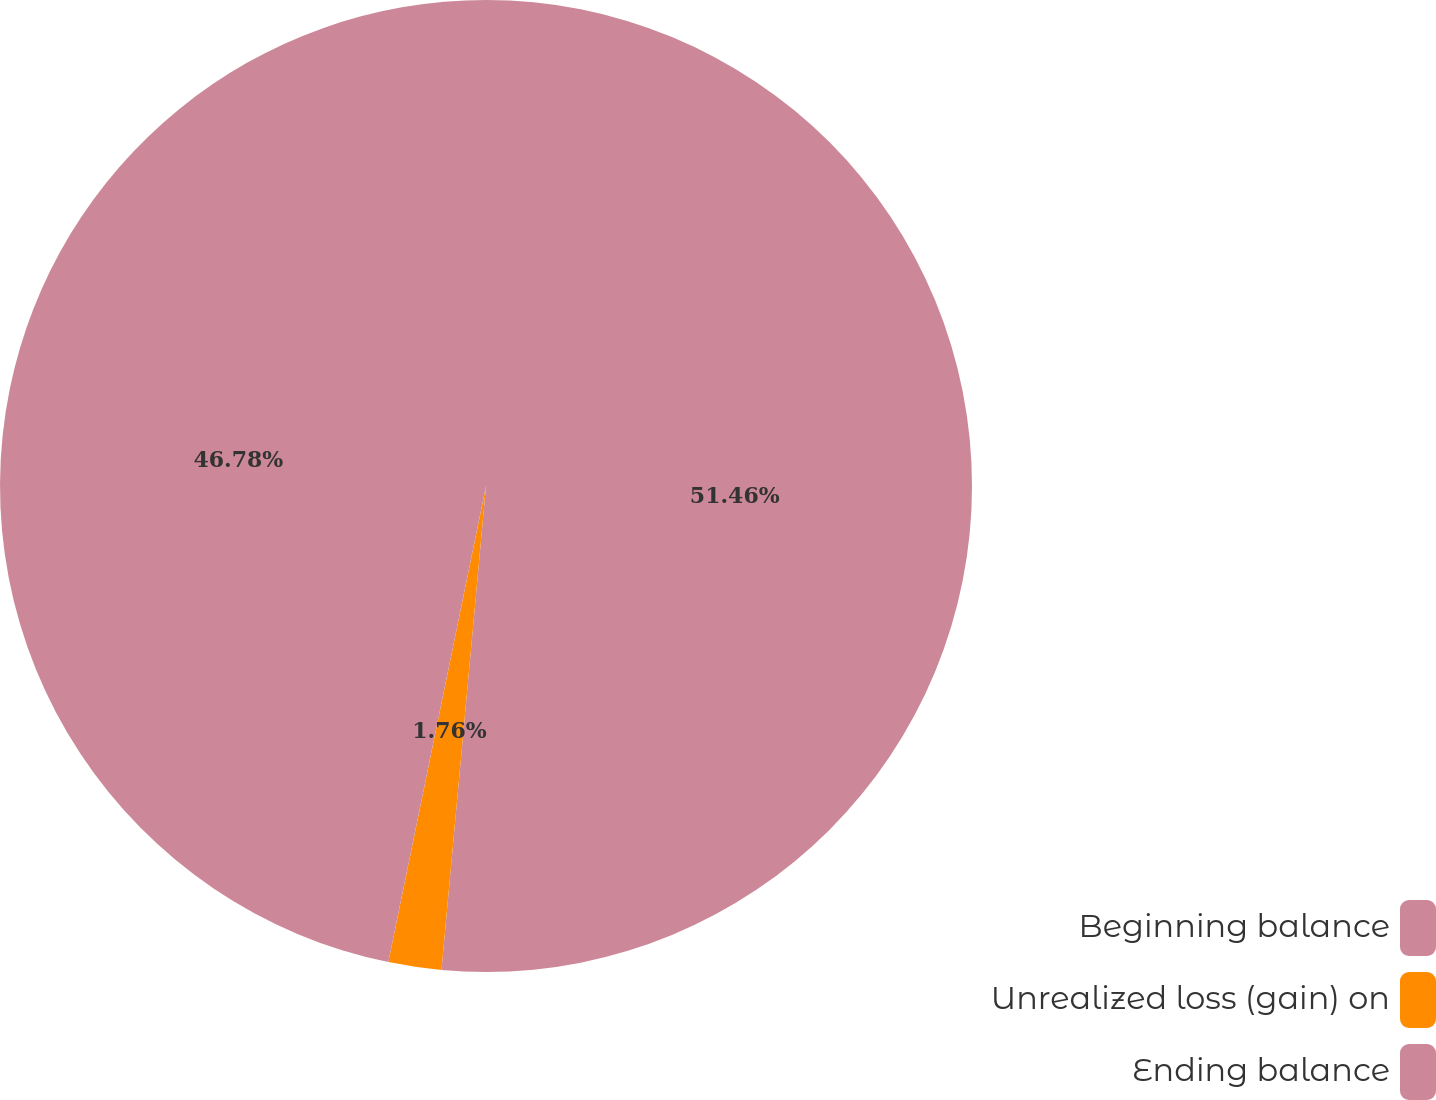<chart> <loc_0><loc_0><loc_500><loc_500><pie_chart><fcel>Beginning balance<fcel>Unrealized loss (gain) on<fcel>Ending balance<nl><fcel>51.46%<fcel>1.76%<fcel>46.78%<nl></chart> 